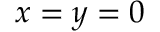Convert formula to latex. <formula><loc_0><loc_0><loc_500><loc_500>x = y = 0</formula> 